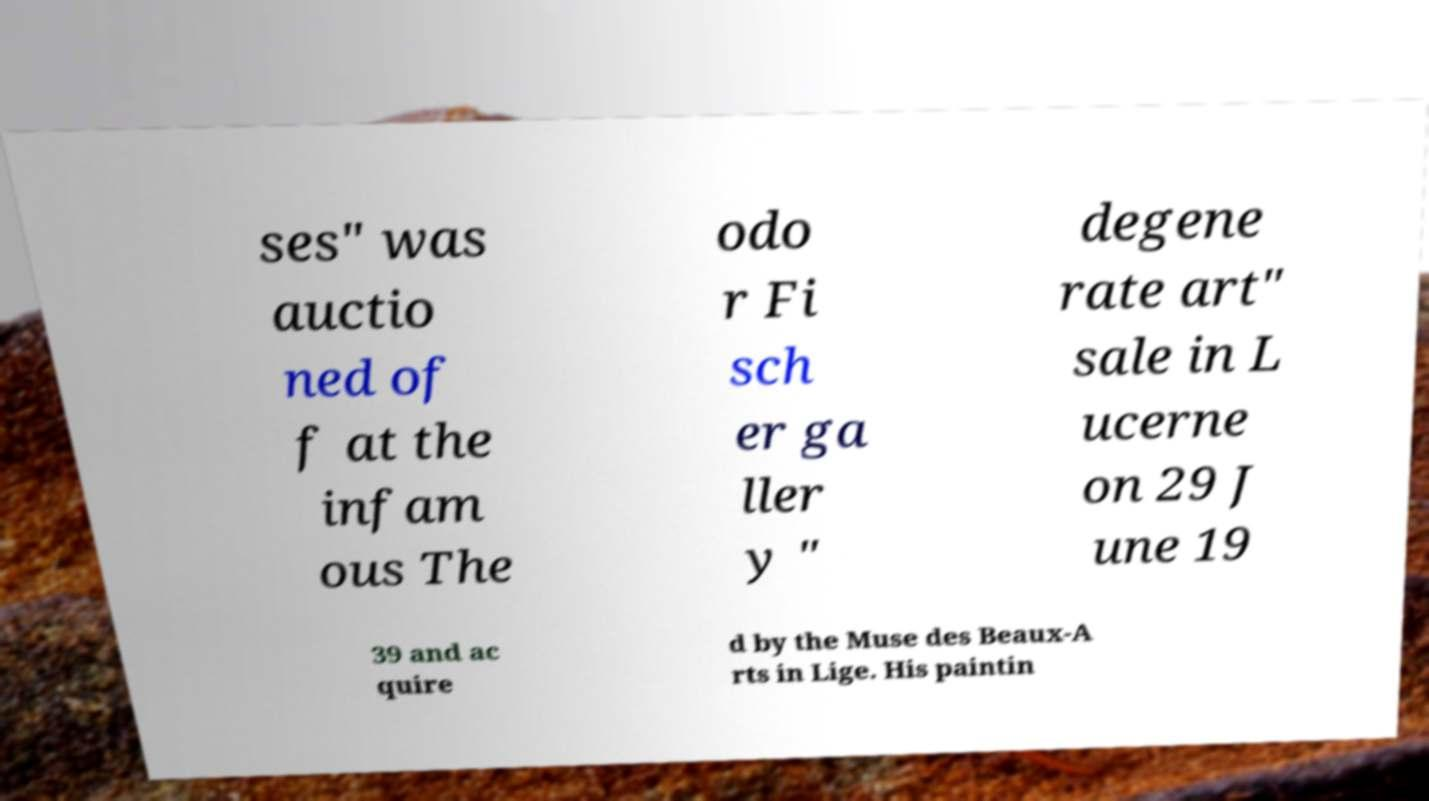For documentation purposes, I need the text within this image transcribed. Could you provide that? ses" was auctio ned of f at the infam ous The odo r Fi sch er ga ller y " degene rate art" sale in L ucerne on 29 J une 19 39 and ac quire d by the Muse des Beaux-A rts in Lige. His paintin 